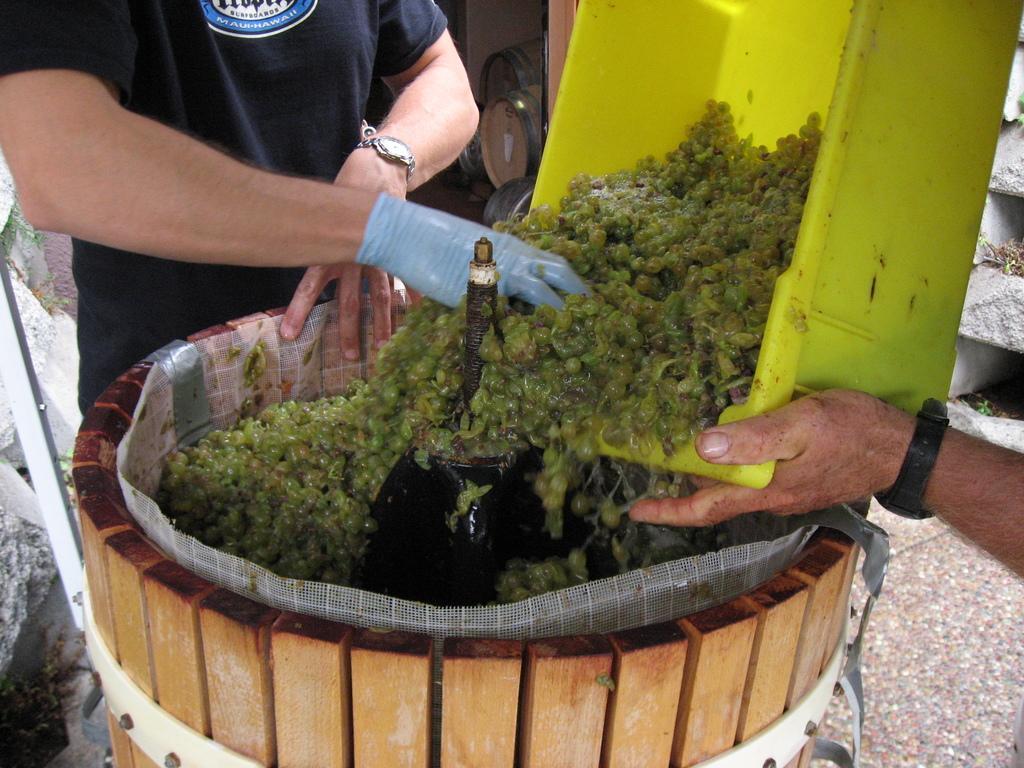How would you summarize this image in a sentence or two? This look like ,they are preparing some food this man wearing a gloves. 